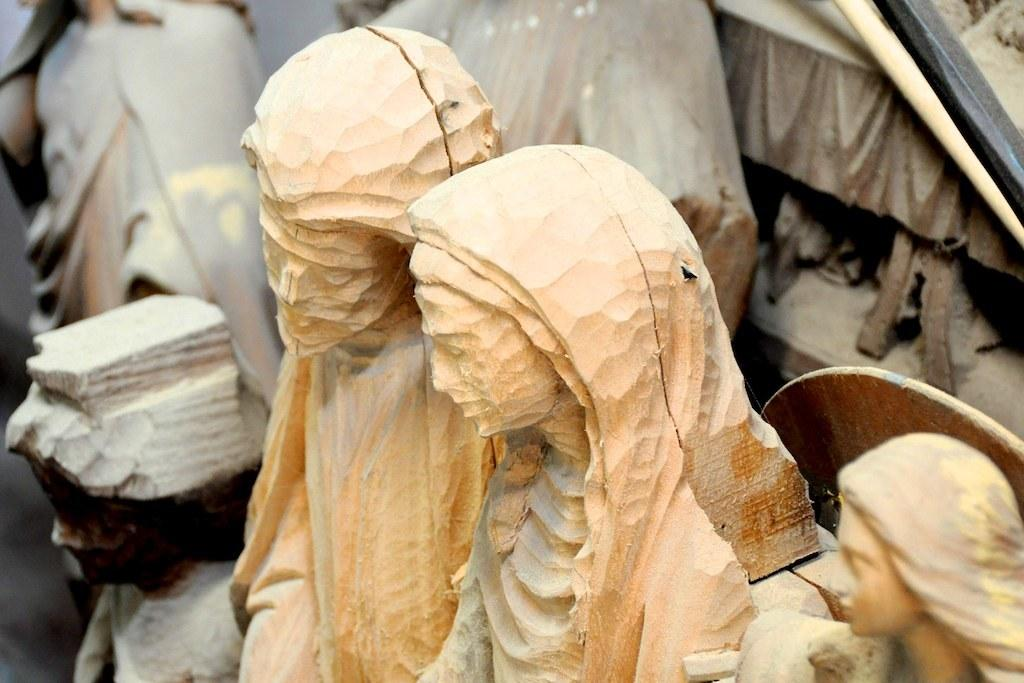What objects are present in the image? There are statues in the image. What material can be seen in the image? There is wood visible in the image. Where is the metal rod located in the image? The metal rod is in the right top of the image. What type of ant can be seen crawling on the statues in the image? There are no ants present in the image; it only features statues, wood, and a metal rod. What type of medical advice can be obtained from the statues in the image? The statues in the image are not capable of providing medical advice, as they are inanimate objects. 